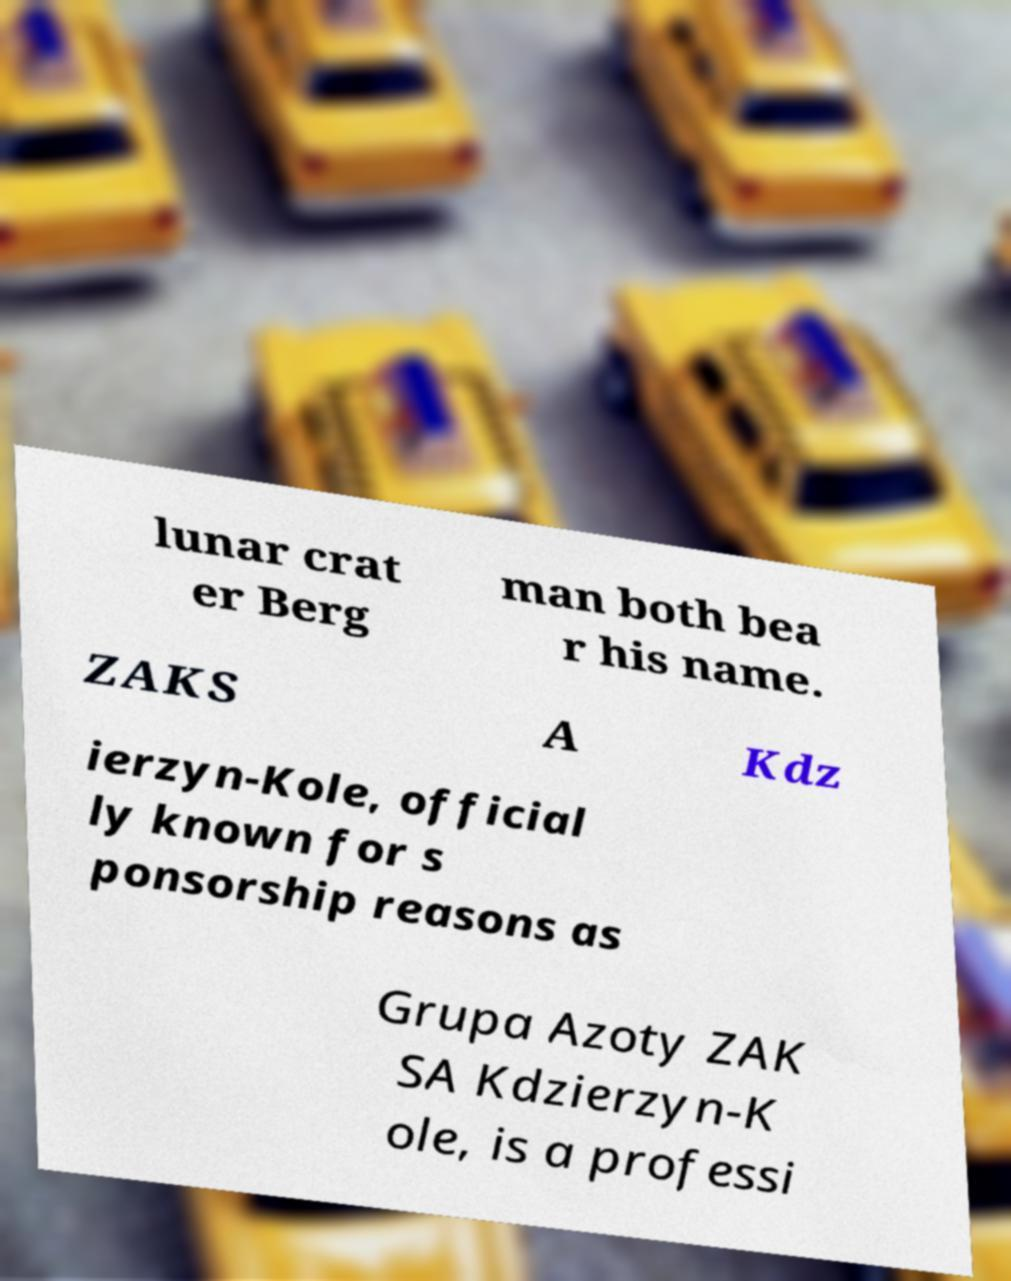There's text embedded in this image that I need extracted. Can you transcribe it verbatim? lunar crat er Berg man both bea r his name. ZAKS A Kdz ierzyn-Kole, official ly known for s ponsorship reasons as Grupa Azoty ZAK SA Kdzierzyn-K ole, is a professi 